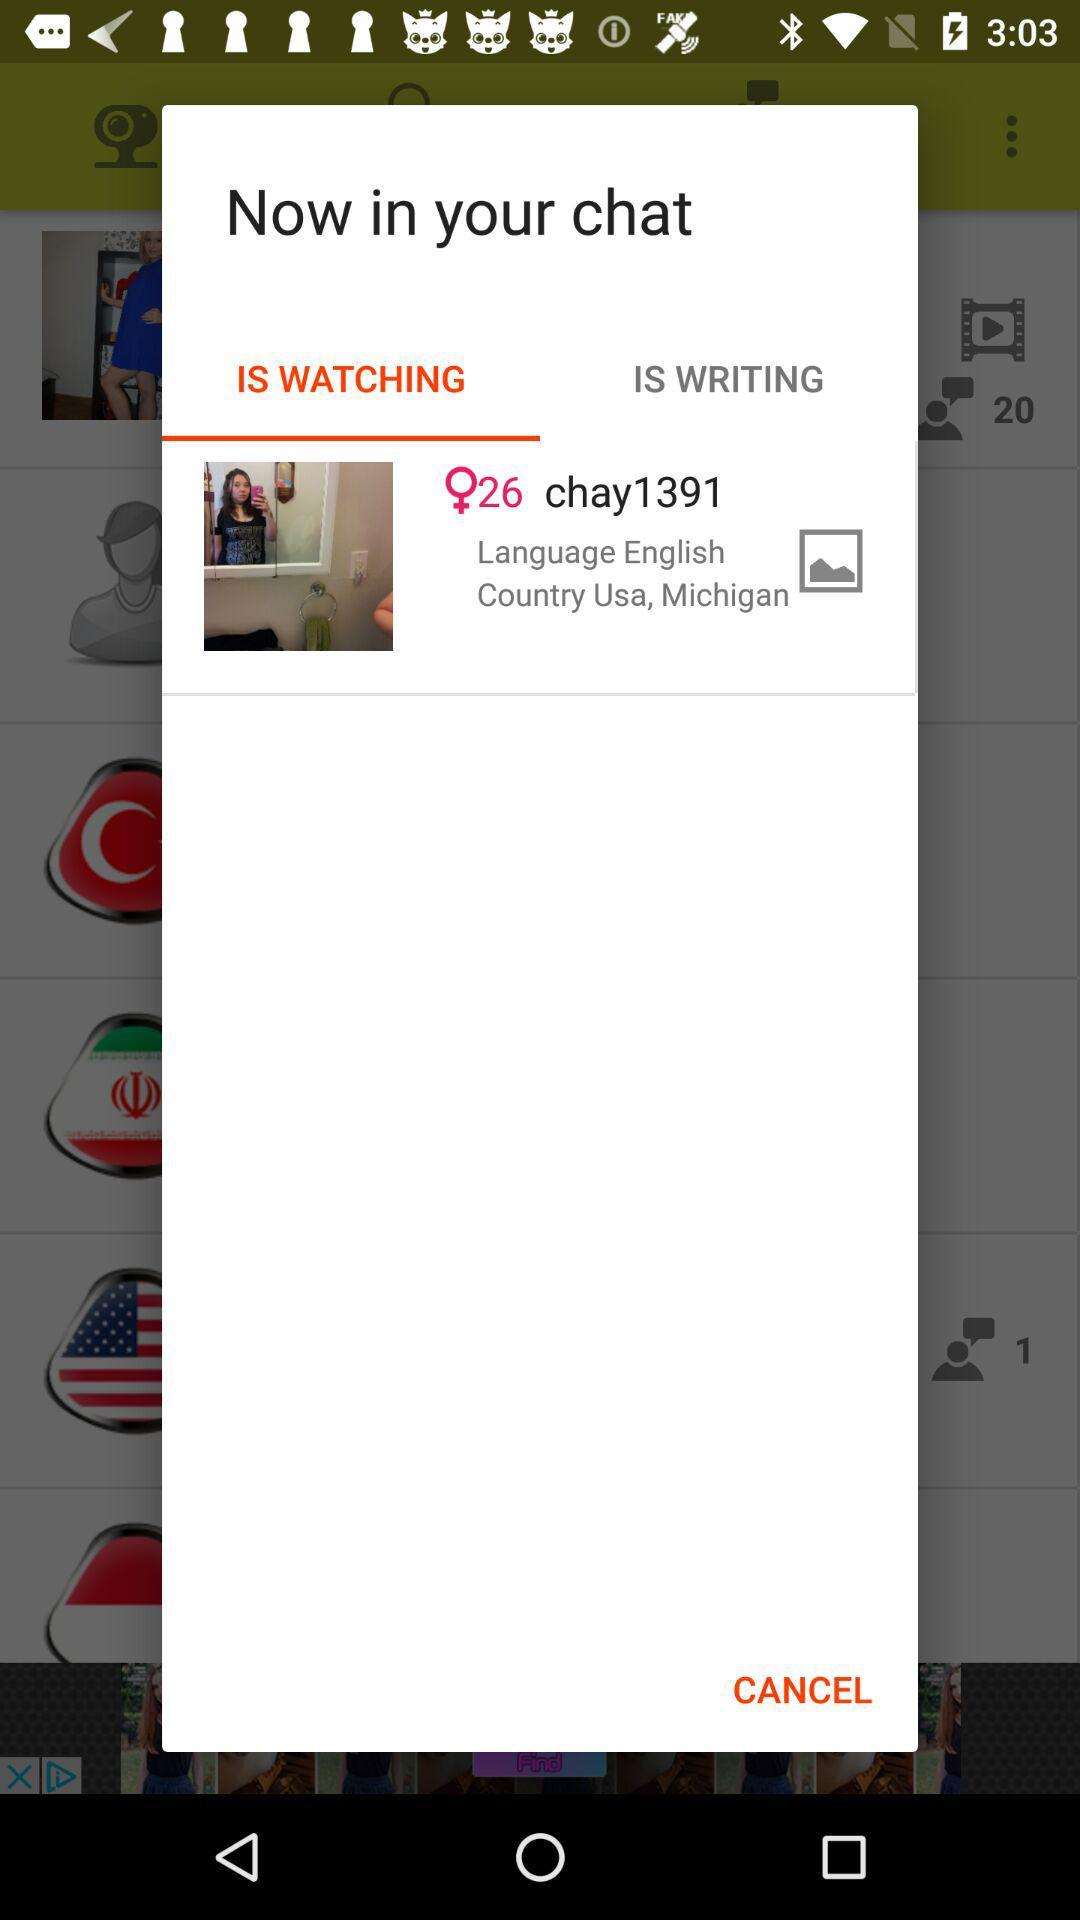What is the age of the user? The age of the user is 26. 